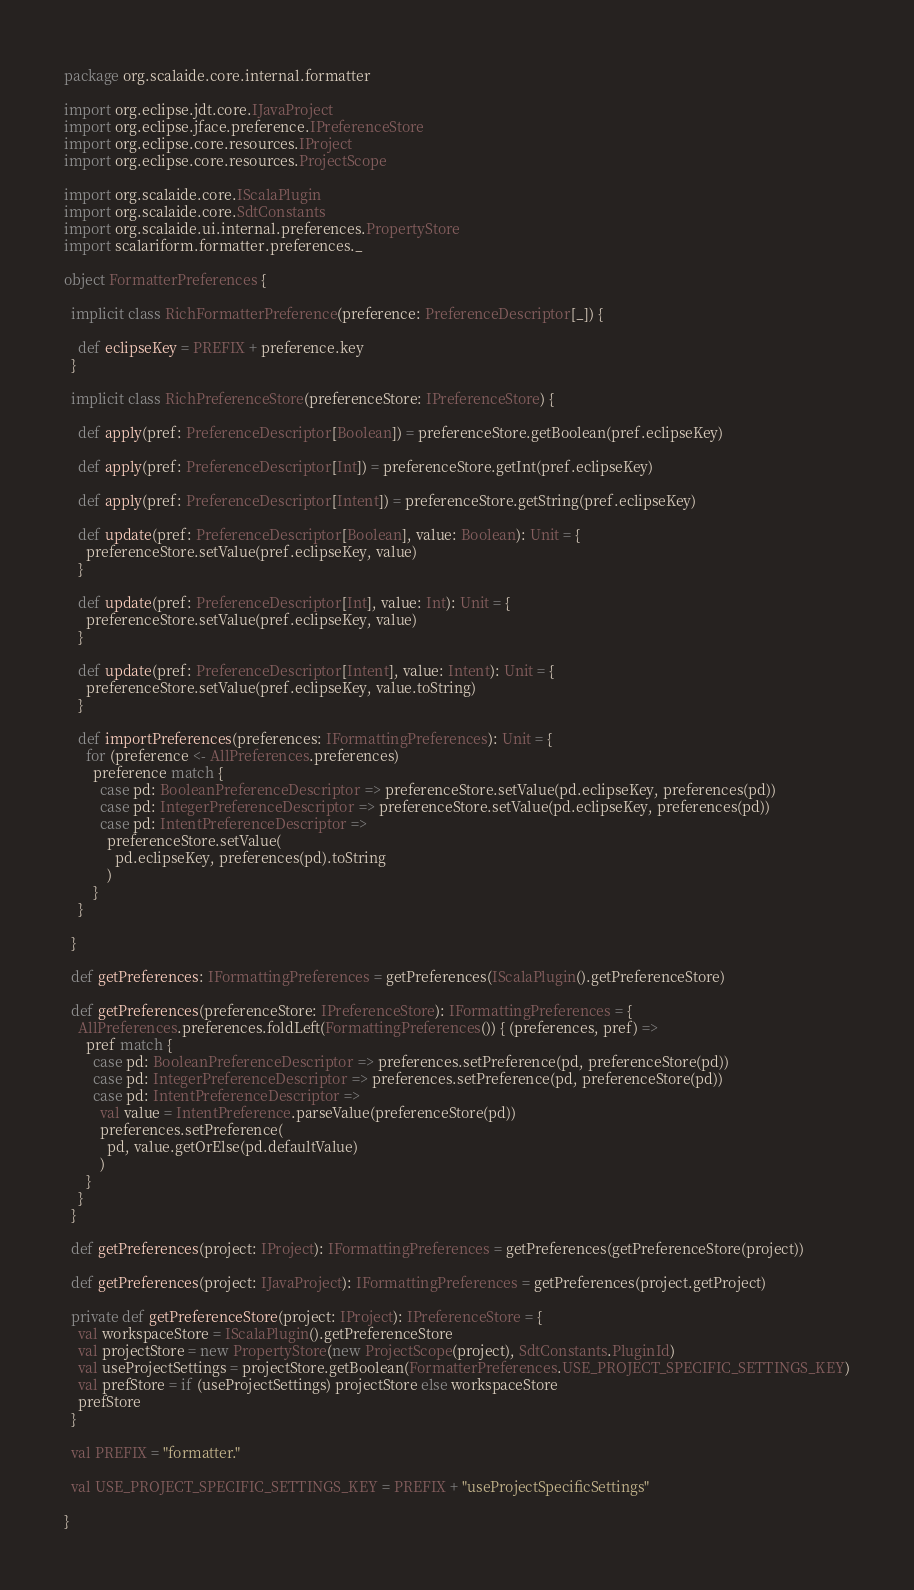Convert code to text. <code><loc_0><loc_0><loc_500><loc_500><_Scala_>package org.scalaide.core.internal.formatter

import org.eclipse.jdt.core.IJavaProject
import org.eclipse.jface.preference.IPreferenceStore
import org.eclipse.core.resources.IProject
import org.eclipse.core.resources.ProjectScope

import org.scalaide.core.IScalaPlugin
import org.scalaide.core.SdtConstants
import org.scalaide.ui.internal.preferences.PropertyStore
import scalariform.formatter.preferences._

object FormatterPreferences {

  implicit class RichFormatterPreference(preference: PreferenceDescriptor[_]) {

    def eclipseKey = PREFIX + preference.key
  }

  implicit class RichPreferenceStore(preferenceStore: IPreferenceStore) {

    def apply(pref: PreferenceDescriptor[Boolean]) = preferenceStore.getBoolean(pref.eclipseKey)

    def apply(pref: PreferenceDescriptor[Int]) = preferenceStore.getInt(pref.eclipseKey)

    def apply(pref: PreferenceDescriptor[Intent]) = preferenceStore.getString(pref.eclipseKey)

    def update(pref: PreferenceDescriptor[Boolean], value: Boolean): Unit = {
      preferenceStore.setValue(pref.eclipseKey, value)
    }

    def update(pref: PreferenceDescriptor[Int], value: Int): Unit = {
      preferenceStore.setValue(pref.eclipseKey, value)
    }

    def update(pref: PreferenceDescriptor[Intent], value: Intent): Unit = {
      preferenceStore.setValue(pref.eclipseKey, value.toString)
    }

    def importPreferences(preferences: IFormattingPreferences): Unit = {
      for (preference <- AllPreferences.preferences)
        preference match {
          case pd: BooleanPreferenceDescriptor => preferenceStore.setValue(pd.eclipseKey, preferences(pd))
          case pd: IntegerPreferenceDescriptor => preferenceStore.setValue(pd.eclipseKey, preferences(pd))
          case pd: IntentPreferenceDescriptor =>
            preferenceStore.setValue(
              pd.eclipseKey, preferences(pd).toString
            )
        }
    }

  }

  def getPreferences: IFormattingPreferences = getPreferences(IScalaPlugin().getPreferenceStore)

  def getPreferences(preferenceStore: IPreferenceStore): IFormattingPreferences = {
    AllPreferences.preferences.foldLeft(FormattingPreferences()) { (preferences, pref) =>
      pref match {
        case pd: BooleanPreferenceDescriptor => preferences.setPreference(pd, preferenceStore(pd))
        case pd: IntegerPreferenceDescriptor => preferences.setPreference(pd, preferenceStore(pd))
        case pd: IntentPreferenceDescriptor =>
          val value = IntentPreference.parseValue(preferenceStore(pd))
          preferences.setPreference(
            pd, value.getOrElse(pd.defaultValue)
          )
      }
    }
  }

  def getPreferences(project: IProject): IFormattingPreferences = getPreferences(getPreferenceStore(project))

  def getPreferences(project: IJavaProject): IFormattingPreferences = getPreferences(project.getProject)

  private def getPreferenceStore(project: IProject): IPreferenceStore = {
    val workspaceStore = IScalaPlugin().getPreferenceStore
    val projectStore = new PropertyStore(new ProjectScope(project), SdtConstants.PluginId)
    val useProjectSettings = projectStore.getBoolean(FormatterPreferences.USE_PROJECT_SPECIFIC_SETTINGS_KEY)
    val prefStore = if (useProjectSettings) projectStore else workspaceStore
    prefStore
  }

  val PREFIX = "formatter."

  val USE_PROJECT_SPECIFIC_SETTINGS_KEY = PREFIX + "useProjectSpecificSettings"

}
</code> 